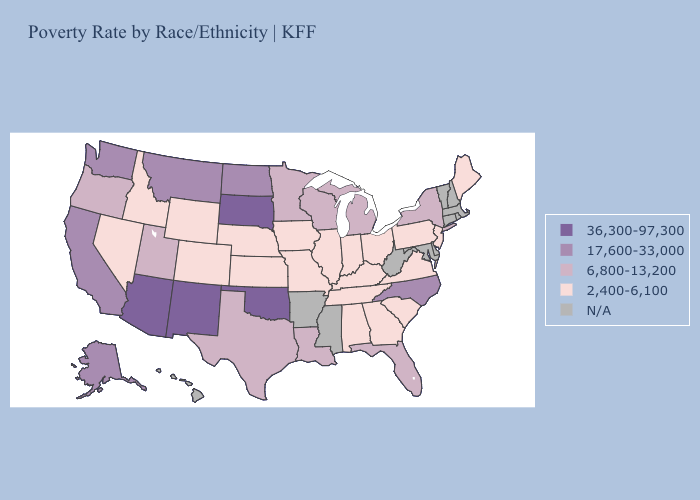What is the lowest value in states that border North Dakota?
Write a very short answer. 6,800-13,200. Does Oklahoma have the highest value in the USA?
Write a very short answer. Yes. Does Michigan have the lowest value in the MidWest?
Answer briefly. No. What is the value of Maine?
Short answer required. 2,400-6,100. What is the value of South Dakota?
Give a very brief answer. 36,300-97,300. Name the states that have a value in the range 6,800-13,200?
Quick response, please. Florida, Louisiana, Michigan, Minnesota, New York, Oregon, Texas, Utah, Wisconsin. What is the value of Colorado?
Short answer required. 2,400-6,100. Among the states that border West Virginia , which have the highest value?
Concise answer only. Kentucky, Ohio, Pennsylvania, Virginia. What is the value of Arkansas?
Quick response, please. N/A. Which states have the lowest value in the USA?
Answer briefly. Alabama, Colorado, Georgia, Idaho, Illinois, Indiana, Iowa, Kansas, Kentucky, Maine, Missouri, Nebraska, Nevada, New Jersey, Ohio, Pennsylvania, South Carolina, Tennessee, Virginia, Wyoming. Is the legend a continuous bar?
Be succinct. No. Name the states that have a value in the range 6,800-13,200?
Give a very brief answer. Florida, Louisiana, Michigan, Minnesota, New York, Oregon, Texas, Utah, Wisconsin. Name the states that have a value in the range 2,400-6,100?
Short answer required. Alabama, Colorado, Georgia, Idaho, Illinois, Indiana, Iowa, Kansas, Kentucky, Maine, Missouri, Nebraska, Nevada, New Jersey, Ohio, Pennsylvania, South Carolina, Tennessee, Virginia, Wyoming. 